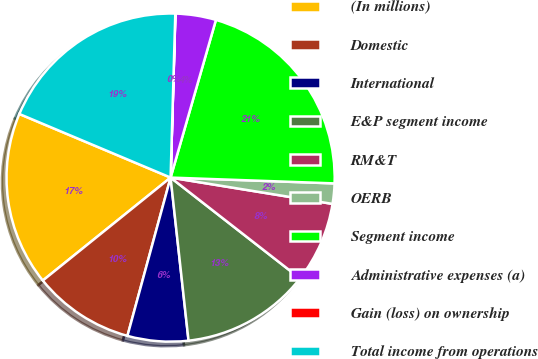<chart> <loc_0><loc_0><loc_500><loc_500><pie_chart><fcel>(In millions)<fcel>Domestic<fcel>International<fcel>E&P segment income<fcel>RM&T<fcel>OERB<fcel>Segment income<fcel>Administrative expenses (a)<fcel>Gain (loss) on ownership<fcel>Total income from operations<nl><fcel>17.13%<fcel>9.97%<fcel>5.98%<fcel>12.72%<fcel>7.97%<fcel>2.0%<fcel>21.11%<fcel>3.99%<fcel>0.01%<fcel>19.12%<nl></chart> 